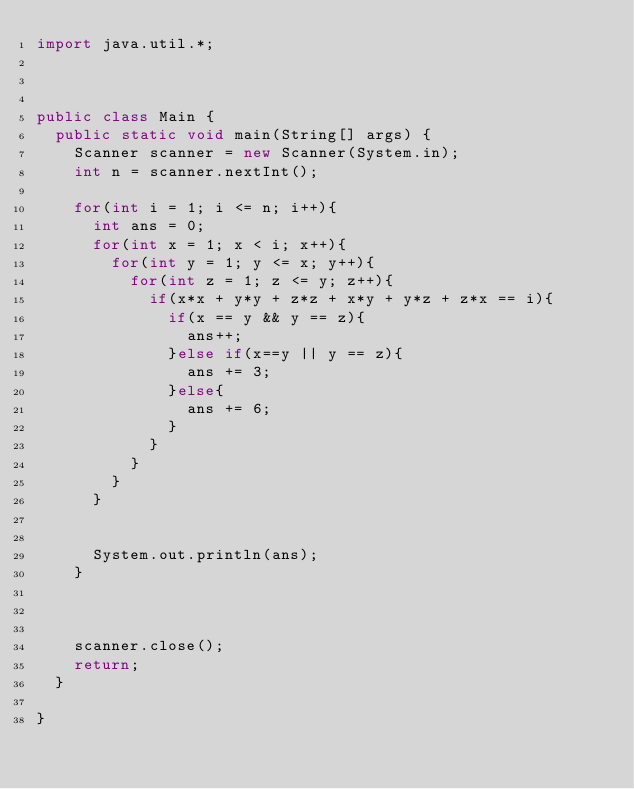<code> <loc_0><loc_0><loc_500><loc_500><_Java_>import java.util.*;



public class Main {
  public static void main(String[] args) {
    Scanner scanner = new Scanner(System.in);
    int n = scanner.nextInt();
    
    for(int i = 1; i <= n; i++){
      int ans = 0;
      for(int x = 1; x < i; x++){
        for(int y = 1; y <= x; y++){
          for(int z = 1; z <= y; z++){
            if(x*x + y*y + z*z + x*y + y*z + z*x == i){
              if(x == y && y == z){
                ans++;
              }else if(x==y || y == z){
                ans += 3;
              }else{
                ans += 6;
              }
            }
          }
        }
      }


      System.out.println(ans);
    }

   
    
    scanner.close();
    return;
  }
  
}
</code> 